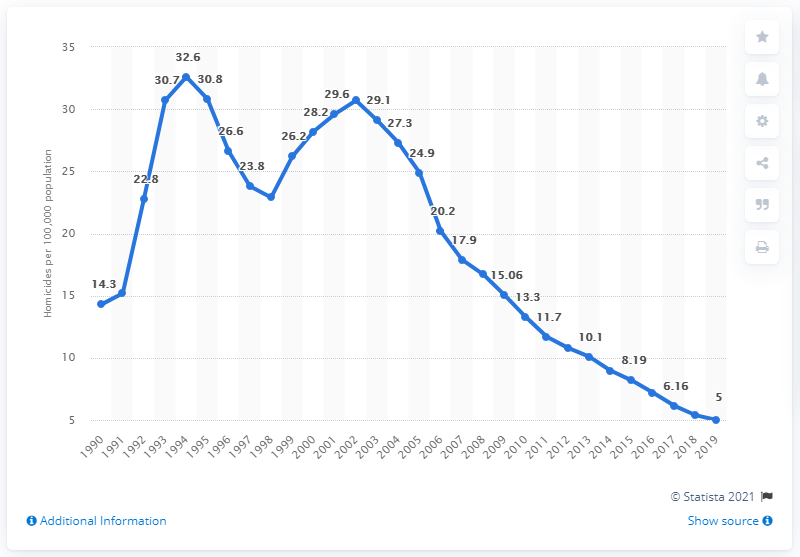Indicate a few pertinent items in this graphic. In 1994, the highest rate of homicides per 100,000 people was 32.6. 